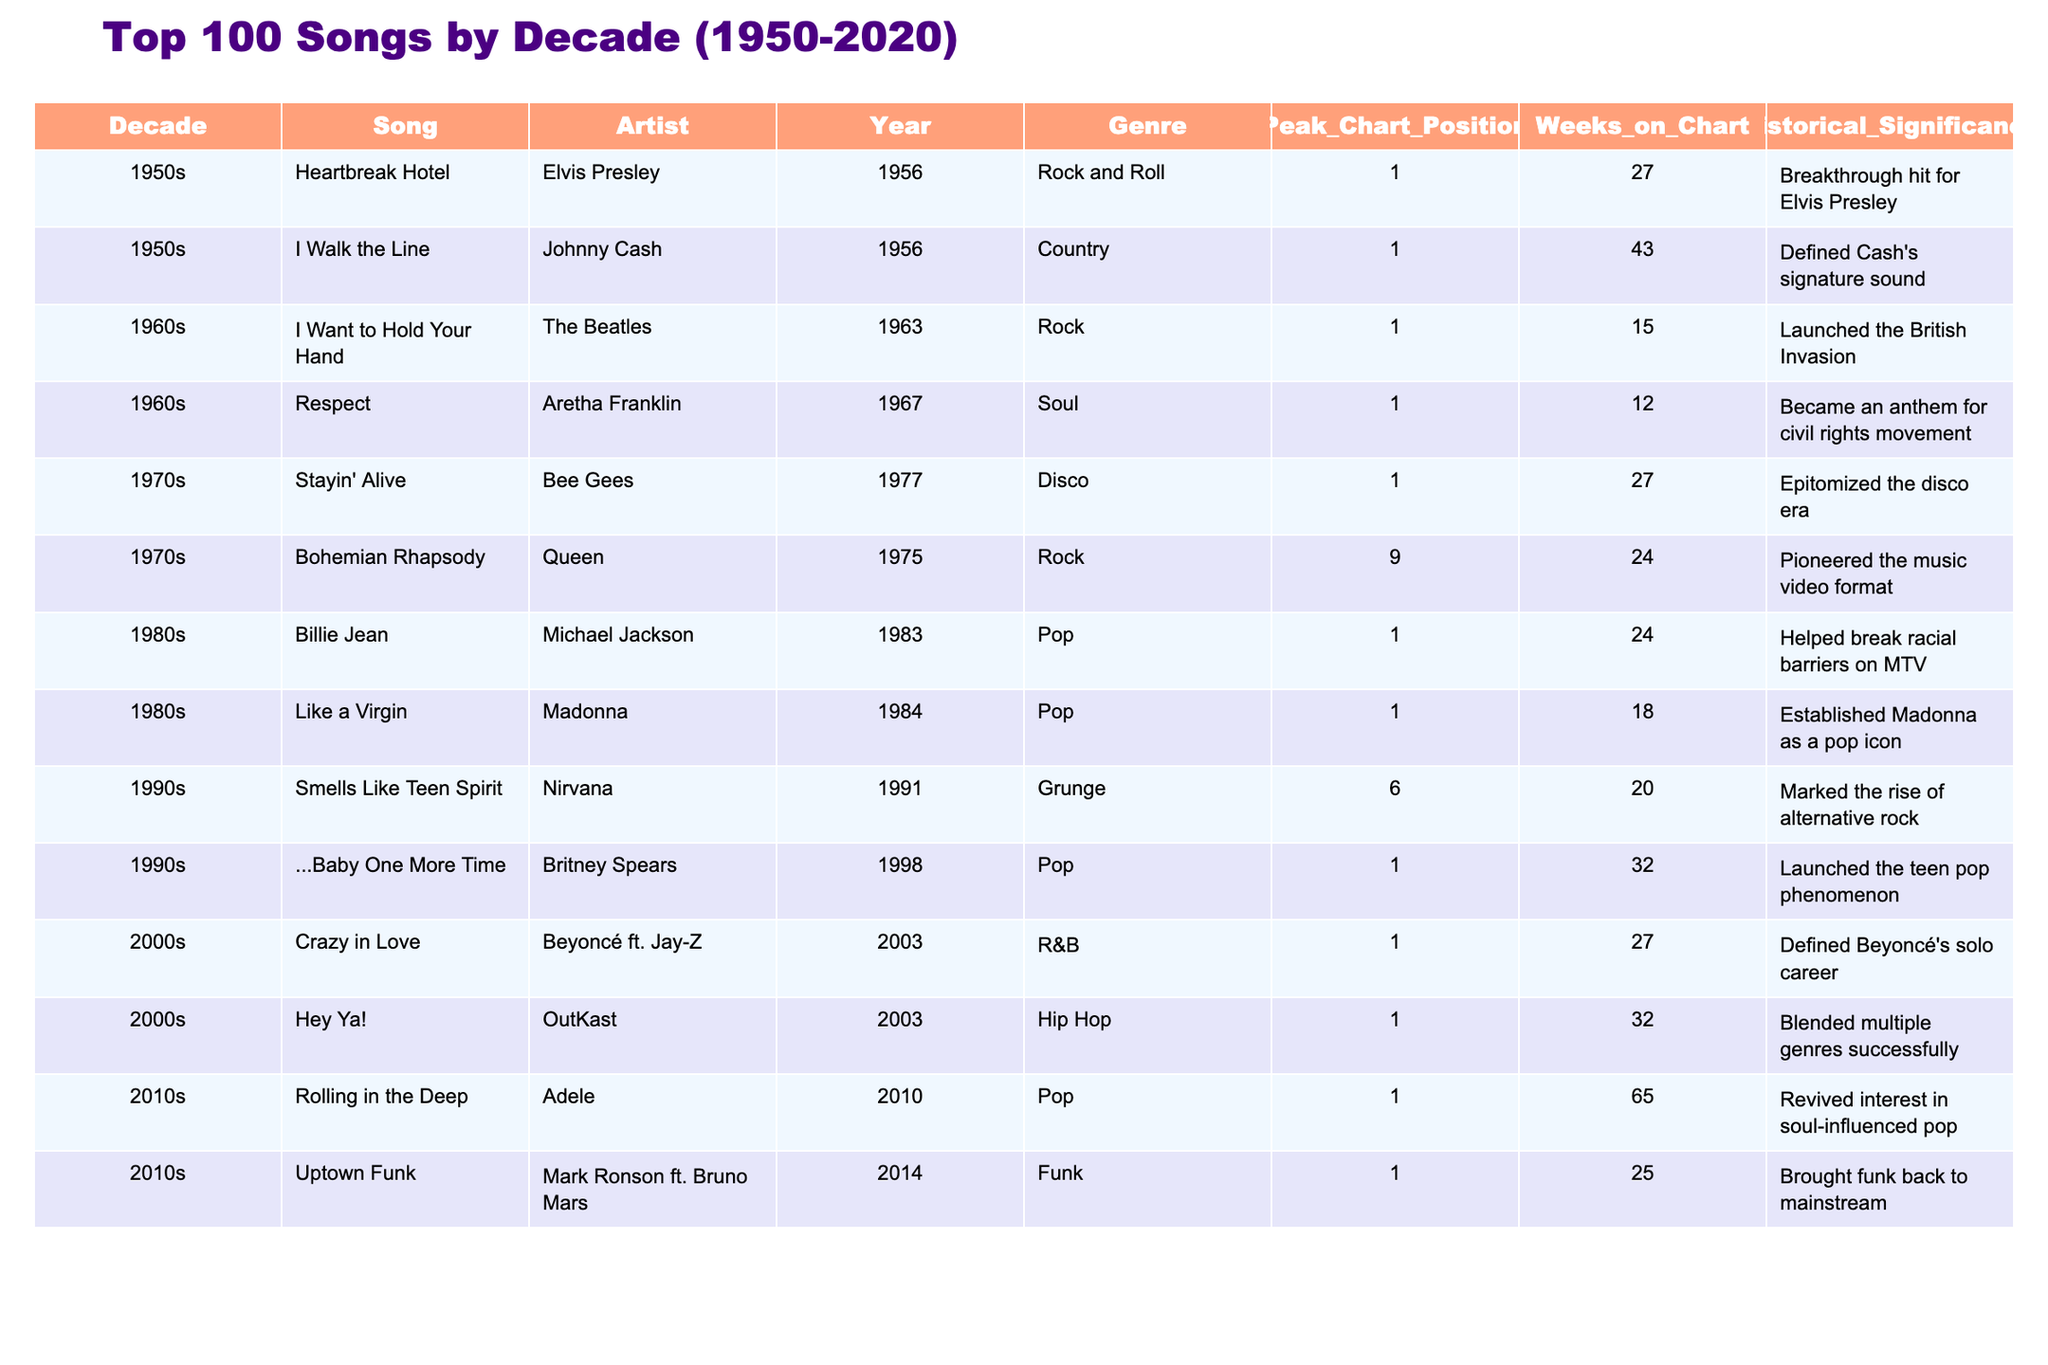What is the highest peak chart position achieved by any song in the 2010s? Looking at the 2010s section of the table, both "Rolling in the Deep" and "Uptown Funk" achieved a peak chart position of 1. Therefore, the highest peak chart position in this decade is 1.
Answer: 1 Which song has the historical significance of becoming an anthem for the civil rights movement? By scanning the historical significance column, "Respect" by Aretha Franklin is noted to have become an anthem for the civil rights movement.
Answer: Respect How many weeks did "Billie Jean" stay on the chart? The table indicates that "Billie Jean" spent 24 weeks on the chart, which is stated in the column for weeks on chart.
Answer: 24 Is "Heartbreak Hotel" associated with the Rock and Roll genre? According to the genre column, "Heartbreak Hotel" is classified as Rock and Roll. Hence, it is true that it is associated with this genre.
Answer: Yes Which song had the longest weeks on the chart in the 2000s? Reviewing the weeks on chart for the 2000s, "Hey Ya!" has 32 weeks and "Crazy in Love" has 27 weeks. Thus, "Hey Ya!" has the longest duration on the chart with 32 weeks.
Answer: Hey Ya! What is the average peak chart position of songs from the 1970s? The peak chart positions for the 1970s songs are 1 for "Stayin' Alive" and 9 for "Bohemian Rhapsody." Adding them gives 1 + 9 = 10, and there are 2 songs, so dividing gives 10/2 = 5.
Answer: 5 Which artist achieved a peak position of 1 with a song released in 1991? Focusing on the year 1991, the table shows that "Smells Like Teen Spirit" by Nirvana reached a peak position of 6, which does not meet the criteria. Therefore, no artist achieved a peak position of 1 in this year.
Answer: None Name the genre of the song "Like a Virgin." By checking the genre column for "Like a Virgin," it is classified under Pop.
Answer: Pop What song from the 2000s launched the teen pop phenomenon? Referring to the historical significance of the songs in the 2000s, "...Baby One More Time" by Britney Spears is noted to have launched the teen pop phenomenon.
Answer: ...Baby One More Time Which decade saw a song that brought funk back to mainstream music? In the table, "Uptown Funk" by Mark Ronson ft. Bruno Mars from the 2010s is noted for bringing funk back to mainstream music.
Answer: 2010s How does the peak chart position of "I Want to Hold Your Hand" compare to "Billie Jean"? "I Want to Hold Your Hand" reached a peak of 1, while "Billie Jean" reached 1 as well; hence both songs have the same peak chart position of 1.
Answer: Same (1) 